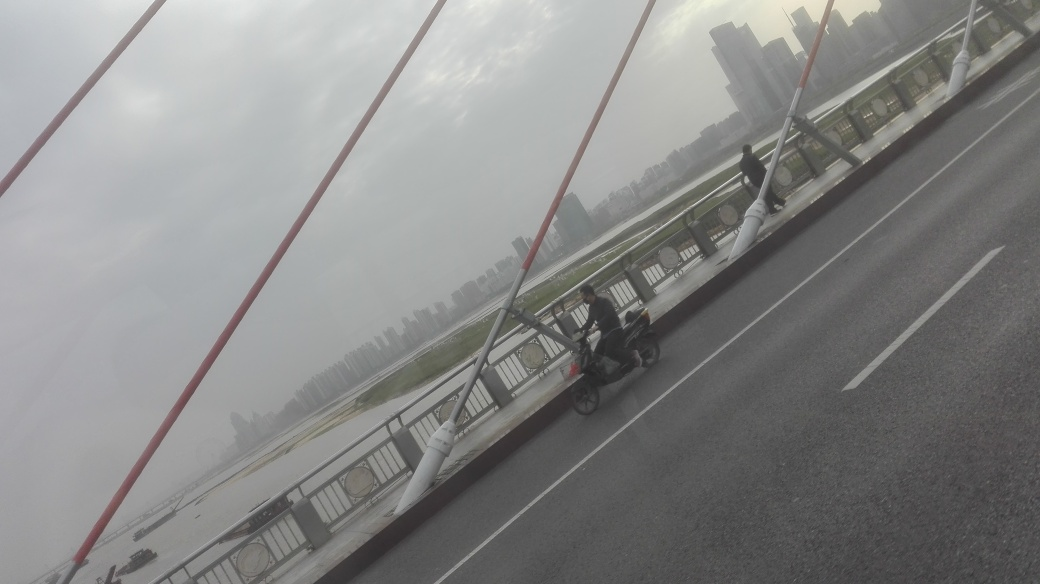What time of day does this photo appear to have been taken? Given the cloudy sky and the lighting, it looks like it could be early morning or late afternoon, times when the sunlight is not as intense. 